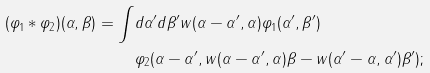Convert formula to latex. <formula><loc_0><loc_0><loc_500><loc_500>( \varphi _ { 1 } \ast \varphi _ { 2 } ) ( \alpha , \beta ) = \int & d \alpha ^ { \prime } d \beta ^ { \prime } w ( \alpha - \alpha ^ { \prime } , \alpha ) \varphi _ { 1 } ( \alpha ^ { \prime } , \beta ^ { \prime } ) \\ & \varphi _ { 2 } ( \alpha - \alpha ^ { \prime } , w ( \alpha - \alpha ^ { \prime } , \alpha ) \beta - w ( \alpha ^ { \prime } - \alpha , \alpha ^ { \prime } ) \beta ^ { \prime } ) ;</formula> 